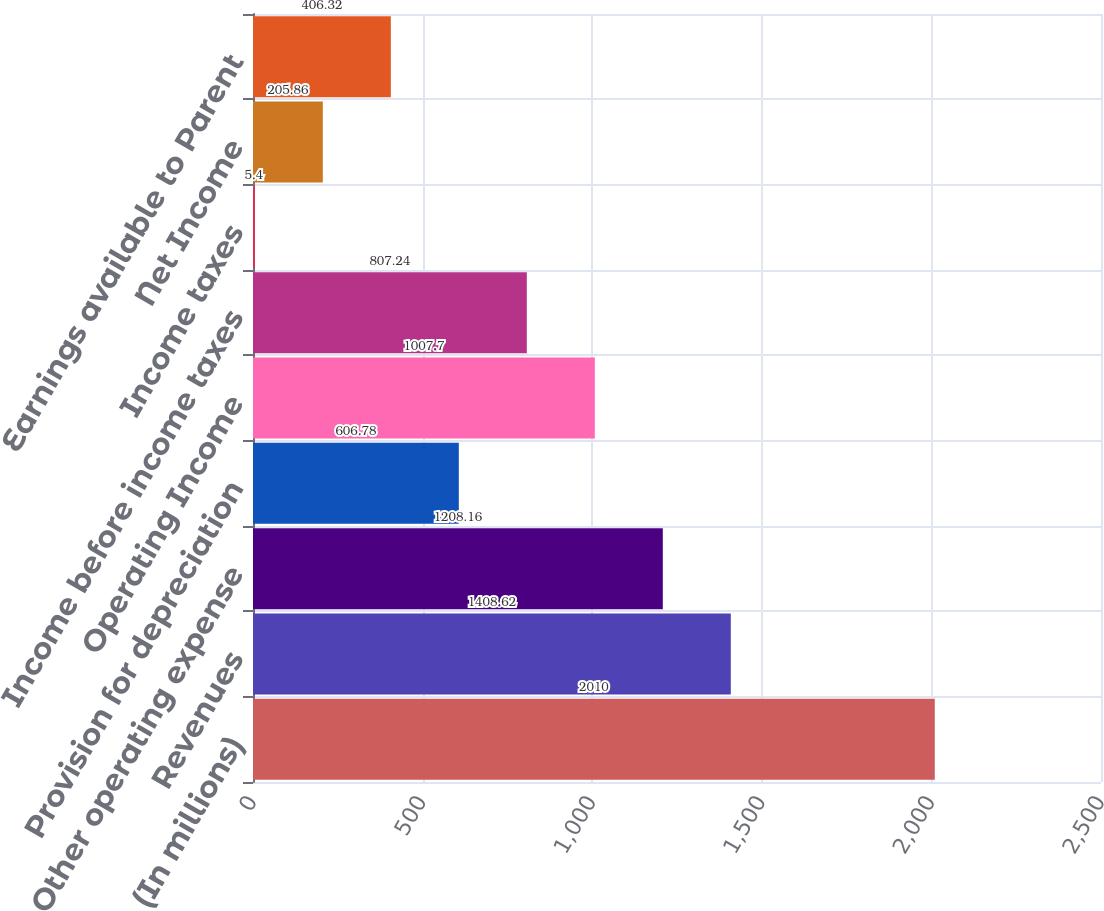Convert chart. <chart><loc_0><loc_0><loc_500><loc_500><bar_chart><fcel>(In millions)<fcel>Revenues<fcel>Other operating expense<fcel>Provision for depreciation<fcel>Operating Income<fcel>Income before income taxes<fcel>Income taxes<fcel>Net Income<fcel>Earnings available to Parent<nl><fcel>2010<fcel>1408.62<fcel>1208.16<fcel>606.78<fcel>1007.7<fcel>807.24<fcel>5.4<fcel>205.86<fcel>406.32<nl></chart> 